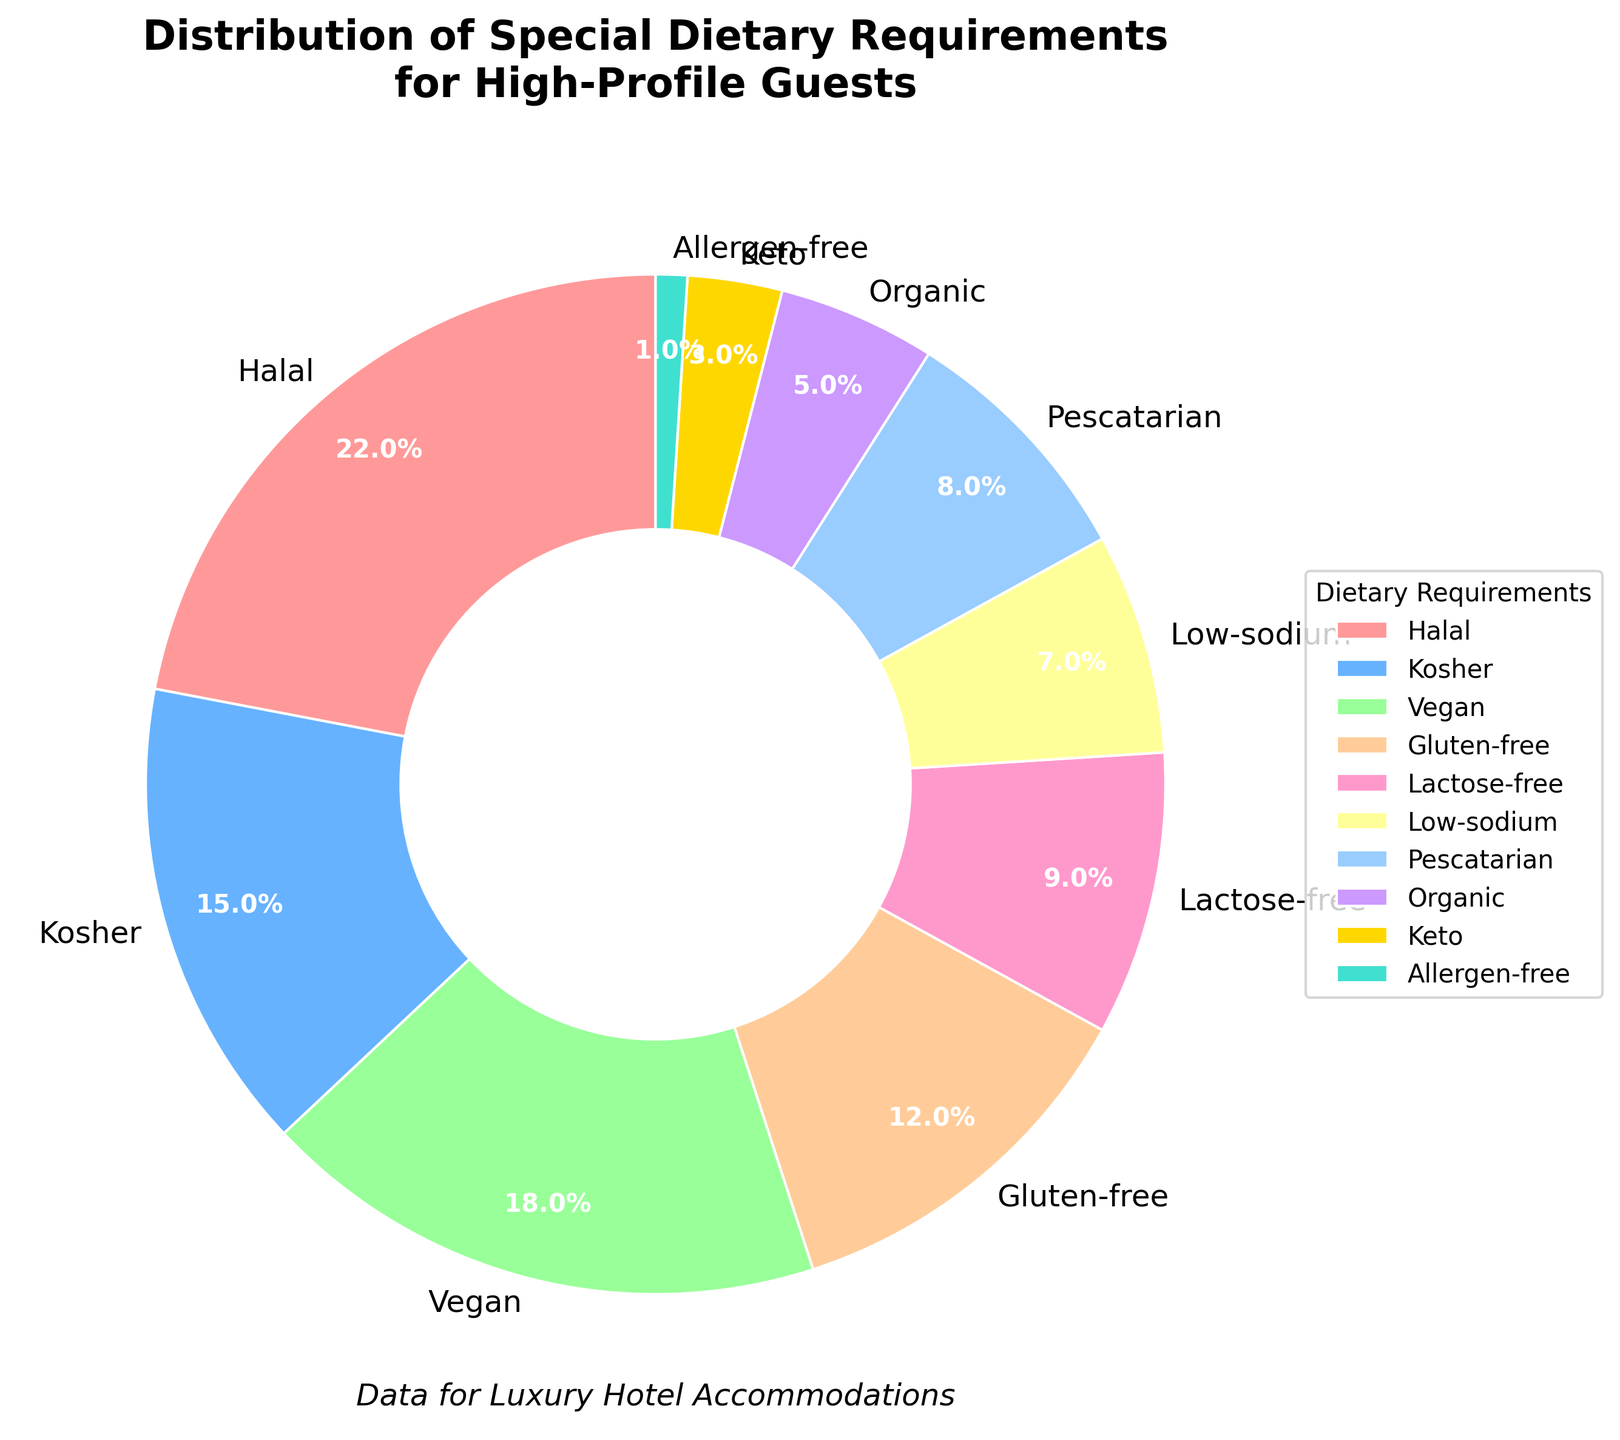Which dietary requirement has the highest percentage? By observing the pie chart, identify the segment with the largest area, which is represented by Halal. The percentage is also annotated on the chart.
Answer: Halal Which dietary requirement has the smallest percentage? By observing the pie chart, identify the segment with the smallest area, which is represented by Allergen-free. The percentage is also annotated on the chart.
Answer: Allergen-free How many dietary requirements constitute more than 10% each? By observing the annotations in the pie chart, count the number of segments where the percentage is greater than 10. Halal (22%), Kosher (15%), Vegan (18%), and Gluten-free (12%) are the segments with percentages greater than 10%.
Answer: 4 What is the combined percentage of Vegan and Gluten-free dietary requirements? Sum the percentages for Vegan and Gluten-free provided in the annotations: 18% (Vegan) + 12% (Gluten-free) = 30%.
Answer: 30% Are there more guests requiring Kosher or Lactose-free dietary requirements? Compare the percentages provided in the annotations for Kosher and Lactose-free. Kosher has 15% while Lactose-free has 9%. Kosher is higher.
Answer: Kosher Which dietary requirement represented in purple? Identify the color associated with the purple segment in the pie chart. Based on the custom color palette, Organic is the purple segment.
Answer: Organic What's the percentage difference between Halal and Keto dietary requirements? Subtract the percentage of Keto dietary requirements from that of Halal: 22% (Halal) - 3% (Keto) = 19%.
Answer: 19% Which dietary requirement is visually represented by a blue segment? Identify the color associated with the blue segment in the pie chart. Based on the custom color palette, Kosher is the blue segment.
Answer: Kosher What is the combined percentage of all dietary requirements less than 10% each? Sum the percentages of segments with less than 10%: Lactose-free (9%) + Low-sodium (7%) + Pescatarian (8%) + Organic (5%) + Keto (3%) + Allergen-free (1%) = 33%.
Answer: 33% Which is larger, the total percentage of Halal and Vegan requirements combined or the total percentage of Kosher and Pescatarian combined? Calculate the total for Halal and Vegan: 22% (Halal) + 18% (Vegan) = 40%. Then calculate the total for Kosher and Pescatarian: 15% (Kosher) + 8% (Pescatarian) = 23%. Halal and Vegan combined are larger.
Answer: Halal and Vegan 